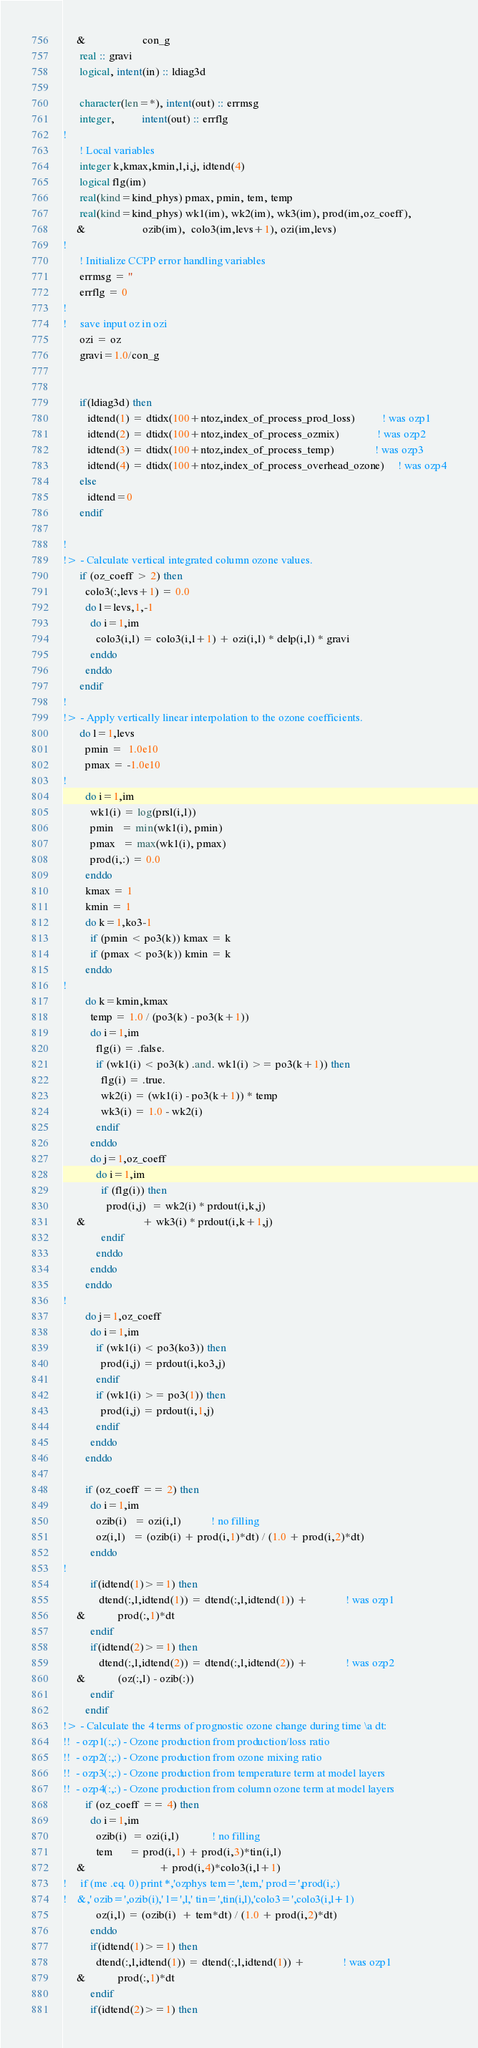Convert code to text. <code><loc_0><loc_0><loc_500><loc_500><_FORTRAN_>     &                     con_g
      real :: gravi
      logical, intent(in) :: ldiag3d
      
      character(len=*), intent(out) :: errmsg
      integer,          intent(out) :: errflg
!
      ! Local variables
      integer k,kmax,kmin,l,i,j, idtend(4)
      logical flg(im)
      real(kind=kind_phys) pmax, pmin, tem, temp
      real(kind=kind_phys) wk1(im), wk2(im), wk3(im), prod(im,oz_coeff),
     &                     ozib(im),  colo3(im,levs+1), ozi(im,levs)
!
      ! Initialize CCPP error handling variables
      errmsg = ''
      errflg = 0
!
!     save input oz in ozi
      ozi = oz
      gravi=1.0/con_g


      if(ldiag3d) then
         idtend(1) = dtidx(100+ntoz,index_of_process_prod_loss)          ! was ozp1
         idtend(2) = dtidx(100+ntoz,index_of_process_ozmix)              ! was ozp2
         idtend(3) = dtidx(100+ntoz,index_of_process_temp)               ! was ozp3
         idtend(4) = dtidx(100+ntoz,index_of_process_overhead_ozone)     ! was ozp4
      else
         idtend=0
      endif

!
!> - Calculate vertical integrated column ozone values.
      if (oz_coeff > 2) then
        colo3(:,levs+1) = 0.0
        do l=levs,1,-1
          do i=1,im
            colo3(i,l) = colo3(i,l+1) + ozi(i,l) * delp(i,l) * gravi 
          enddo
        enddo
      endif
!
!> - Apply vertically linear interpolation to the ozone coefficients. 
      do l=1,levs
        pmin =  1.0e10
        pmax = -1.0e10
!
        do i=1,im
          wk1(i) = log(prsl(i,l))
          pmin   = min(wk1(i), pmin)
          pmax   = max(wk1(i), pmax)
          prod(i,:) = 0.0
        enddo
        kmax = 1
        kmin = 1
        do k=1,ko3-1
          if (pmin < po3(k)) kmax = k
          if (pmax < po3(k)) kmin = k
        enddo
!
        do k=kmin,kmax
          temp = 1.0 / (po3(k) - po3(k+1))
          do i=1,im
            flg(i) = .false.
            if (wk1(i) < po3(k) .and. wk1(i) >= po3(k+1)) then
              flg(i) = .true.
              wk2(i) = (wk1(i) - po3(k+1)) * temp
              wk3(i) = 1.0 - wk2(i)
            endif
          enddo
          do j=1,oz_coeff
            do i=1,im
              if (flg(i)) then
                prod(i,j)  = wk2(i) * prdout(i,k,j)
     &                     + wk3(i) * prdout(i,k+1,j)
              endif
            enddo
          enddo
        enddo
!
        do j=1,oz_coeff
          do i=1,im
            if (wk1(i) < po3(ko3)) then
              prod(i,j) = prdout(i,ko3,j)
            endif
            if (wk1(i) >= po3(1)) then
              prod(i,j) = prdout(i,1,j)
            endif
          enddo
        enddo

        if (oz_coeff == 2) then
          do i=1,im
            ozib(i)   = ozi(i,l)           ! no filling
            oz(i,l)   = (ozib(i) + prod(i,1)*dt) / (1.0 + prod(i,2)*dt)
          enddo
!
          if(idtend(1)>=1) then
             dtend(:,l,idtend(1)) = dtend(:,l,idtend(1)) +              ! was ozp1
     &            prod(:,1)*dt
          endif
          if(idtend(2)>=1) then
             dtend(:,l,idtend(2)) = dtend(:,l,idtend(2)) +              ! was ozp2
     &            (oz(:,l) - ozib(:))
          endif
        endif
!> - Calculate the 4 terms of prognostic ozone change during time \a dt:  
!!  - ozp1(:,:) - Ozone production from production/loss ratio 
!!  - ozp2(:,:) - Ozone production from ozone mixing ratio 
!!  - ozp3(:,:) - Ozone production from temperature term at model layers 
!!  - ozp4(:,:) - Ozone production from column ozone term at model layers
        if (oz_coeff == 4) then
          do i=1,im
            ozib(i)  = ozi(i,l)            ! no filling
            tem      = prod(i,1) + prod(i,3)*tin(i,l)
     &                           + prod(i,4)*colo3(i,l+1)
!     if (me .eq. 0) print *,'ozphys tem=',tem,' prod=',prod(i,:)
!    &,' ozib=',ozib(i),' l=',l,' tin=',tin(i,l),'colo3=',colo3(i,l+1)
            oz(i,l) = (ozib(i)  + tem*dt) / (1.0 + prod(i,2)*dt)
          enddo
          if(idtend(1)>=1) then
            dtend(:,l,idtend(1)) = dtend(:,l,idtend(1)) +              ! was ozp1
     &            prod(:,1)*dt
          endif
          if(idtend(2)>=1) then</code> 